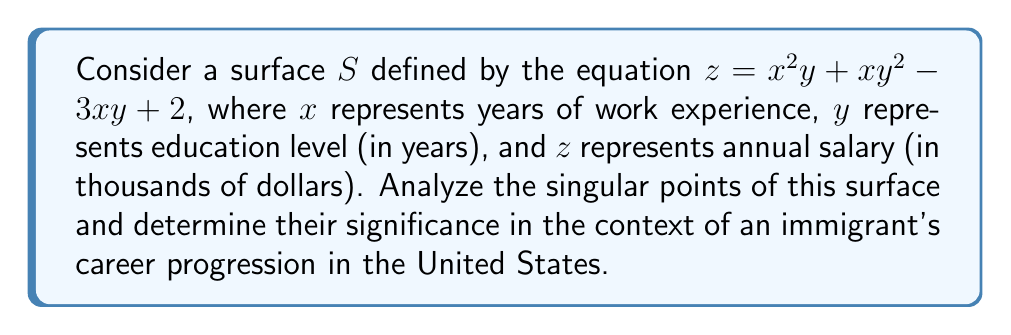Show me your answer to this math problem. 1) To find singular points, we need to calculate the partial derivatives and set them equal to zero:

   $\frac{\partial z}{\partial x} = 2xy + y^2 - 3y$
   $\frac{\partial z}{\partial y} = x^2 + 2xy - 3x$

2) Set both partial derivatives to zero:

   $2xy + y^2 - 3y = 0$
   $x^2 + 2xy - 3x = 0$

3) Solve this system of equations:
   
   From the second equation: $x(x + 2y - 3) = 0$
   So either $x = 0$ or $x + 2y - 3 = 0$

4) Case 1: If $x = 0$, substitute into the first equation:
   
   $y^2 - 3y = 0$
   $y(y - 3) = 0$
   So $y = 0$ or $y = 3$

5) Case 2: If $x + 2y - 3 = 0$, substitute $x = 3 - 2y$ into the first equation:
   
   $2(3-2y)y + y^2 - 3y = 0$
   $6y - 4y^2 + y^2 - 3y = 0$
   $-3y^2 + 3y = 0$
   $3y(1 - y) = 0$
   So $y = 0$ or $y = 1$

6) Combining the results:
   
   Singular points are (0,0), (0,3), and (1,1)

7) Interpretation:
   - (0,0): No education, no experience, minimum salary (2,000$)
   - (0,3): 3 years of education, no experience, potential entry point
   - (1,1): 1 year each of education and experience, balanced growth

These points represent critical junctures in an immigrant's career where small changes in education or experience can lead to significant salary changes.
Answer: Singular points: (0,0), (0,3), (1,1); representing minimum entry, education focus, and balanced growth in an immigrant's career progression. 